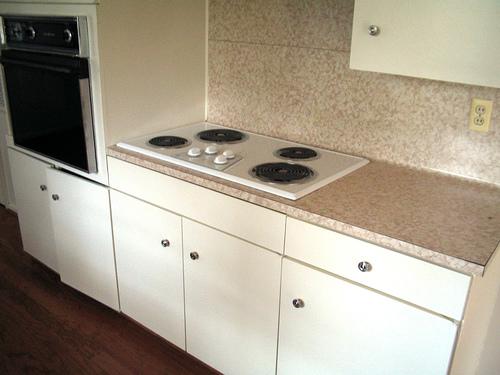Is this safe?
Write a very short answer. Yes. Is the top cabinet open or shut?
Keep it brief. Shut. What is one advantage of the oven placement?
Short answer required. Space. Is this a new kitchen?
Quick response, please. No. 